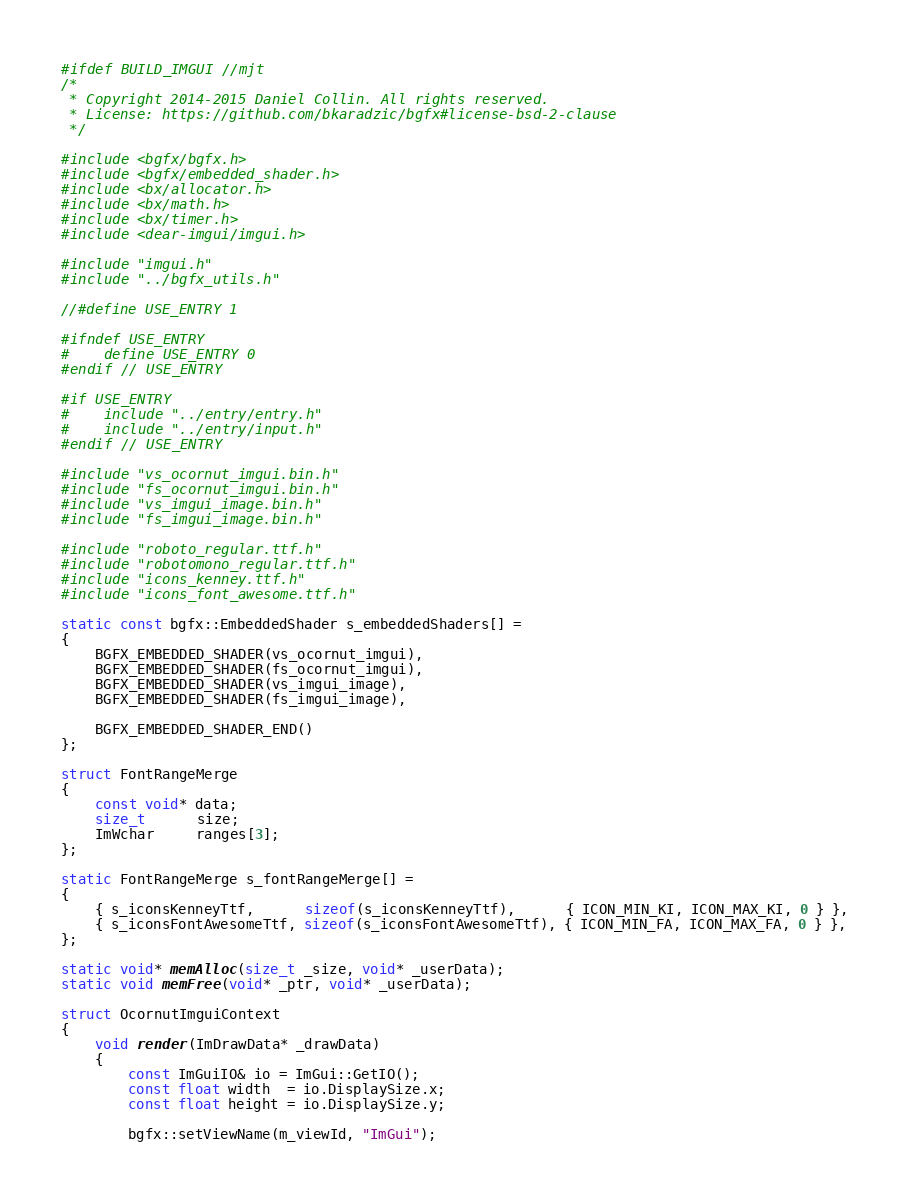Convert code to text. <code><loc_0><loc_0><loc_500><loc_500><_C++_>#ifdef BUILD_IMGUI //mjt
/*
 * Copyright 2014-2015 Daniel Collin. All rights reserved.
 * License: https://github.com/bkaradzic/bgfx#license-bsd-2-clause
 */

#include <bgfx/bgfx.h>
#include <bgfx/embedded_shader.h>
#include <bx/allocator.h>
#include <bx/math.h>
#include <bx/timer.h>
#include <dear-imgui/imgui.h>

#include "imgui.h"
#include "../bgfx_utils.h"

//#define USE_ENTRY 1

#ifndef USE_ENTRY
#	define USE_ENTRY 0
#endif // USE_ENTRY

#if USE_ENTRY
#	include "../entry/entry.h"
#	include "../entry/input.h"
#endif // USE_ENTRY

#include "vs_ocornut_imgui.bin.h"
#include "fs_ocornut_imgui.bin.h"
#include "vs_imgui_image.bin.h"
#include "fs_imgui_image.bin.h"

#include "roboto_regular.ttf.h"
#include "robotomono_regular.ttf.h"
#include "icons_kenney.ttf.h"
#include "icons_font_awesome.ttf.h"

static const bgfx::EmbeddedShader s_embeddedShaders[] =
{
	BGFX_EMBEDDED_SHADER(vs_ocornut_imgui),
	BGFX_EMBEDDED_SHADER(fs_ocornut_imgui),
	BGFX_EMBEDDED_SHADER(vs_imgui_image),
	BGFX_EMBEDDED_SHADER(fs_imgui_image),

	BGFX_EMBEDDED_SHADER_END()
};

struct FontRangeMerge
{
	const void* data;
	size_t      size;
	ImWchar     ranges[3];
};

static FontRangeMerge s_fontRangeMerge[] =
{
	{ s_iconsKenneyTtf,      sizeof(s_iconsKenneyTtf),      { ICON_MIN_KI, ICON_MAX_KI, 0 } },
	{ s_iconsFontAwesomeTtf, sizeof(s_iconsFontAwesomeTtf), { ICON_MIN_FA, ICON_MAX_FA, 0 } },
};

static void* memAlloc(size_t _size, void* _userData);
static void memFree(void* _ptr, void* _userData);

struct OcornutImguiContext
{
	void render(ImDrawData* _drawData)
	{
		const ImGuiIO& io = ImGui::GetIO();
		const float width  = io.DisplaySize.x;
		const float height = io.DisplaySize.y;

		bgfx::setViewName(m_viewId, "ImGui");</code> 